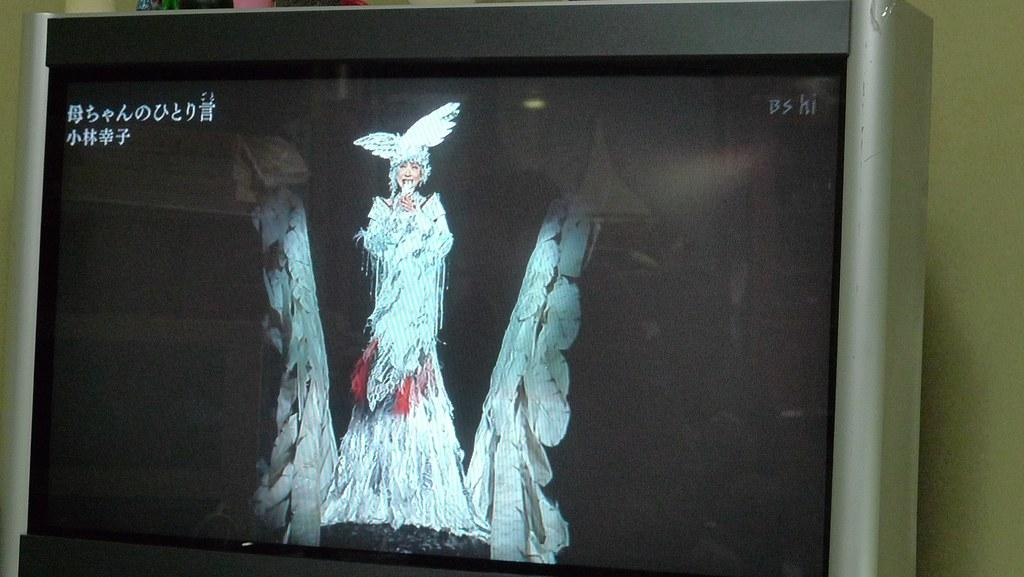What electronic device is present in the image? There is a monitor in the image. What is happening on the monitor screen? A woman is standing on the monitor screen. What can be read on the monitor screen? There is text visible on the monitor screen. What can be seen in the background of the image? There is a wall in the background of the image. What type of bird is flying around the monitor in the image? There is no bird present in the image; it only features a monitor with a woman standing on the screen and text visible. 